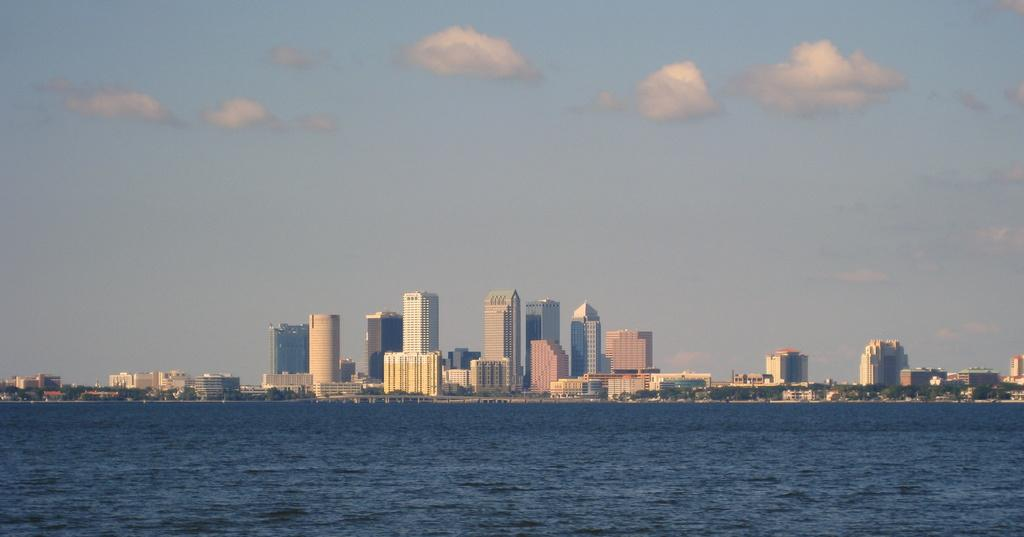What is the primary element visible in the image? There is water in the image. What can be seen in the distance behind the water? There are buildings and trees in the background of the image. What is visible at the top of the image? The sky is visible at the top of the image. Can you see anyone using a rifle in the image? There is no rifle present in the image. Is there a family reading a book together in the image? There is no family or book visible in the image. 